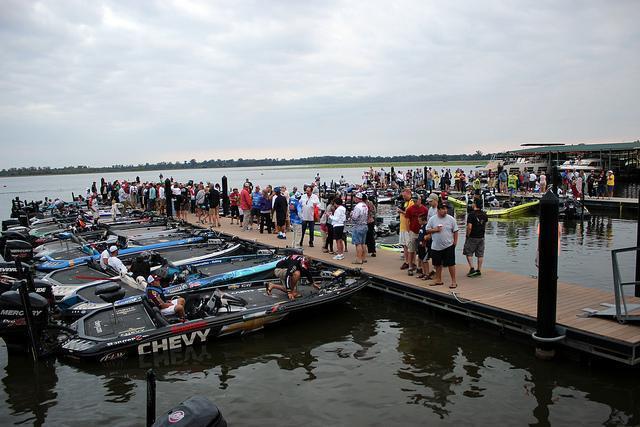How many boats are there?
Give a very brief answer. 3. How many toilet bowl brushes are in this picture?
Give a very brief answer. 0. 